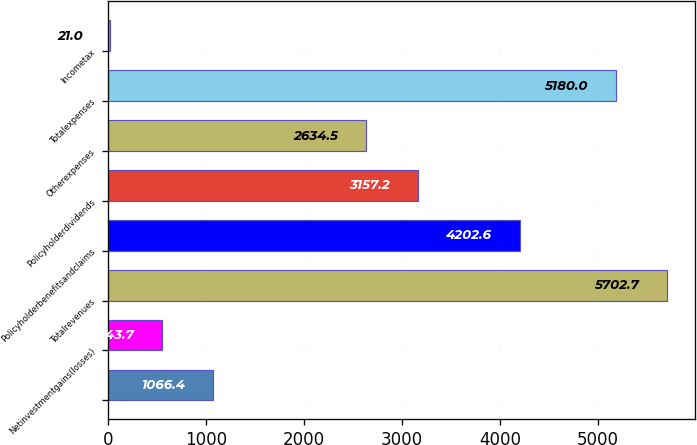<chart> <loc_0><loc_0><loc_500><loc_500><bar_chart><ecel><fcel>Netinvestmentgains(losses)<fcel>Totalrevenues<fcel>Policyholderbenefitsandclaims<fcel>Policyholderdividends<fcel>Otherexpenses<fcel>Totalexpenses<fcel>Incometax<nl><fcel>1066.4<fcel>543.7<fcel>5702.7<fcel>4202.6<fcel>3157.2<fcel>2634.5<fcel>5180<fcel>21<nl></chart> 